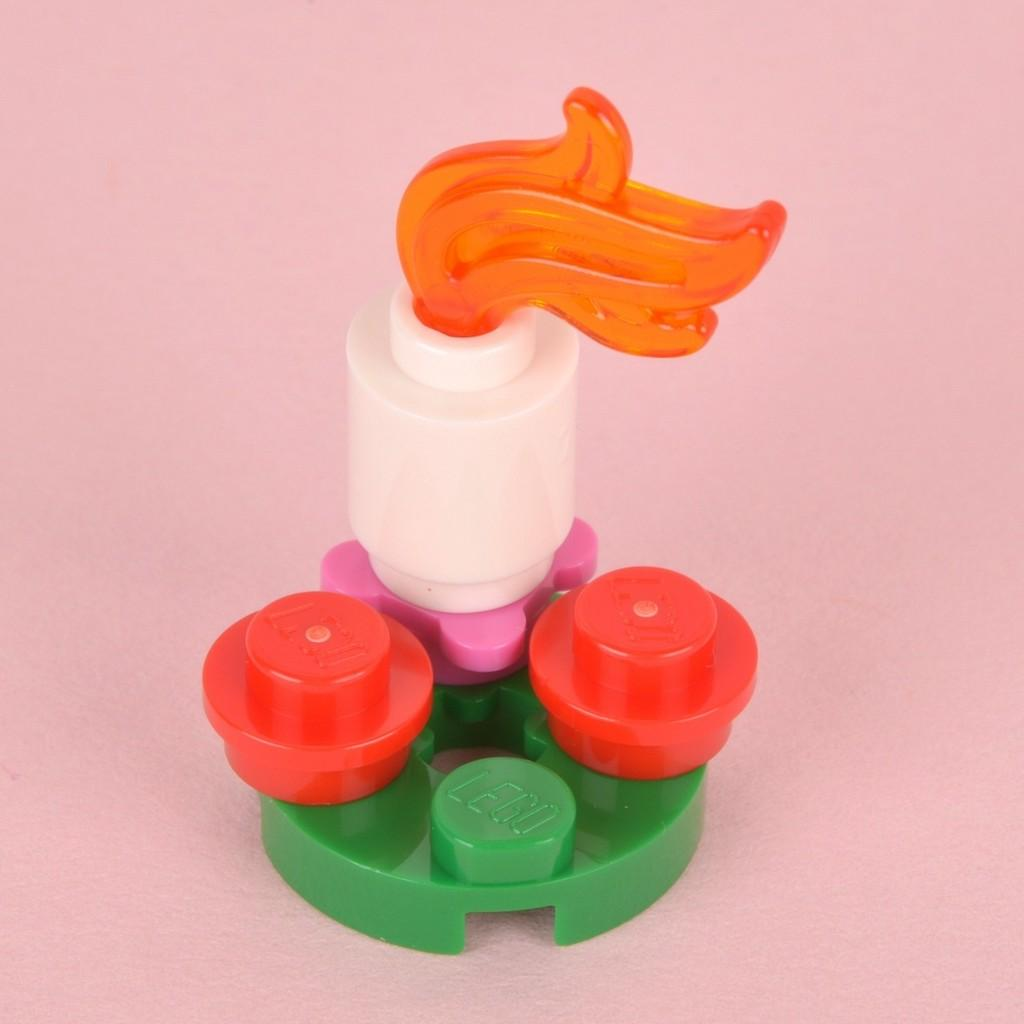What object can be seen in the image? There is a toy in the image. Where is the toy located? The toy is placed on a surface. How many babies are playing with the toy in the image? There are no babies present in the image; it only features a toy placed on a surface. What type of bears can be seen interacting with the toy in the image? There are no bears present in the image; it only features a toy placed on a surface. 